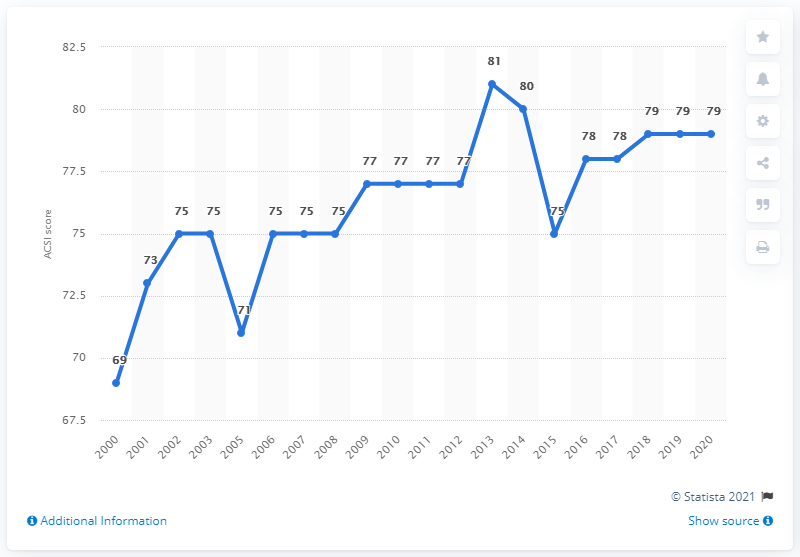Point out several critical features in this image. According to the American Customer Satisfaction Index score in 2020, Domino's Pizza received a score of 79 out of 100, indicating that a large majority of customers were satisfied with the quality of the pizza and services provided by the company. 